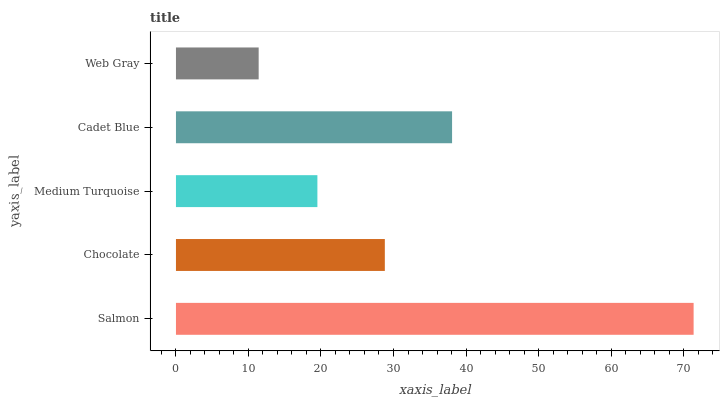Is Web Gray the minimum?
Answer yes or no. Yes. Is Salmon the maximum?
Answer yes or no. Yes. Is Chocolate the minimum?
Answer yes or no. No. Is Chocolate the maximum?
Answer yes or no. No. Is Salmon greater than Chocolate?
Answer yes or no. Yes. Is Chocolate less than Salmon?
Answer yes or no. Yes. Is Chocolate greater than Salmon?
Answer yes or no. No. Is Salmon less than Chocolate?
Answer yes or no. No. Is Chocolate the high median?
Answer yes or no. Yes. Is Chocolate the low median?
Answer yes or no. Yes. Is Salmon the high median?
Answer yes or no. No. Is Cadet Blue the low median?
Answer yes or no. No. 